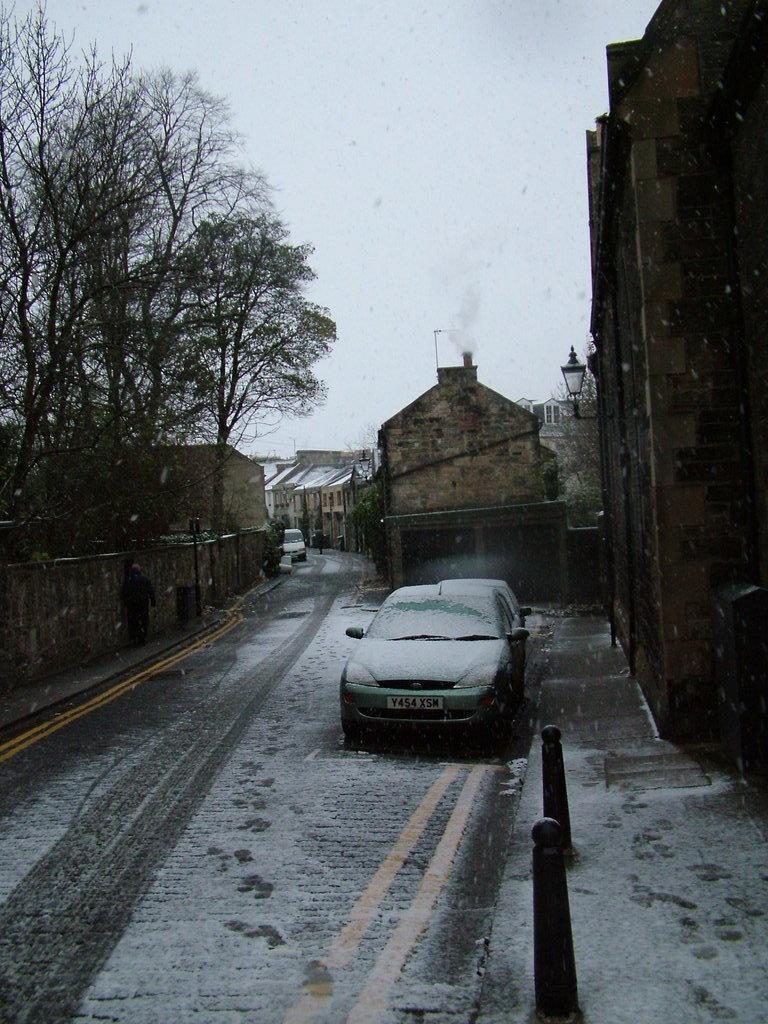Can you describe this image briefly? In this image I see the road on which there is snow and I see few cars and I see number of buildings and trees and I see the sky in the background and I see the poles over here. 